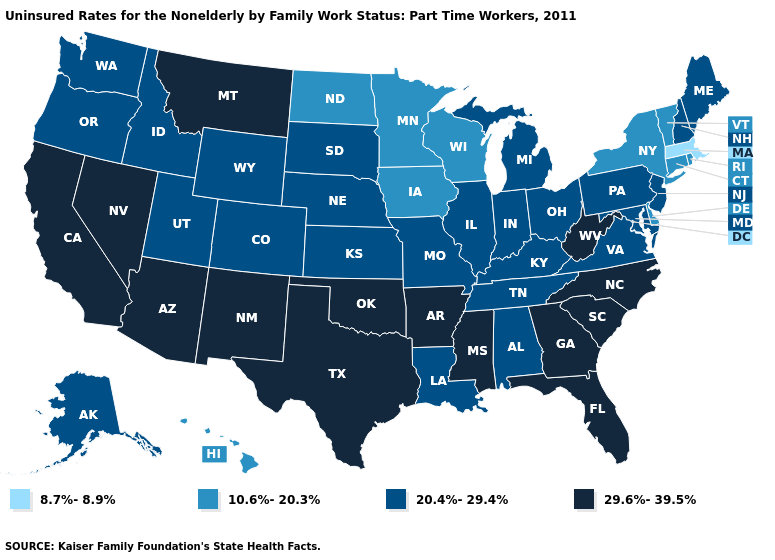What is the value of Tennessee?
Give a very brief answer. 20.4%-29.4%. What is the value of South Carolina?
Be succinct. 29.6%-39.5%. Among the states that border Oklahoma , which have the highest value?
Short answer required. Arkansas, New Mexico, Texas. Name the states that have a value in the range 8.7%-8.9%?
Short answer required. Massachusetts. Among the states that border Maine , which have the highest value?
Be succinct. New Hampshire. Does Kentucky have the same value as Texas?
Give a very brief answer. No. Among the states that border Delaware , which have the highest value?
Quick response, please. Maryland, New Jersey, Pennsylvania. Which states have the highest value in the USA?
Quick response, please. Arizona, Arkansas, California, Florida, Georgia, Mississippi, Montana, Nevada, New Mexico, North Carolina, Oklahoma, South Carolina, Texas, West Virginia. Which states have the highest value in the USA?
Short answer required. Arizona, Arkansas, California, Florida, Georgia, Mississippi, Montana, Nevada, New Mexico, North Carolina, Oklahoma, South Carolina, Texas, West Virginia. Among the states that border Iowa , which have the lowest value?
Write a very short answer. Minnesota, Wisconsin. What is the value of Alaska?
Short answer required. 20.4%-29.4%. What is the value of Mississippi?
Keep it brief. 29.6%-39.5%. Name the states that have a value in the range 20.4%-29.4%?
Give a very brief answer. Alabama, Alaska, Colorado, Idaho, Illinois, Indiana, Kansas, Kentucky, Louisiana, Maine, Maryland, Michigan, Missouri, Nebraska, New Hampshire, New Jersey, Ohio, Oregon, Pennsylvania, South Dakota, Tennessee, Utah, Virginia, Washington, Wyoming. What is the lowest value in the South?
Keep it brief. 10.6%-20.3%. What is the value of Iowa?
Quick response, please. 10.6%-20.3%. 